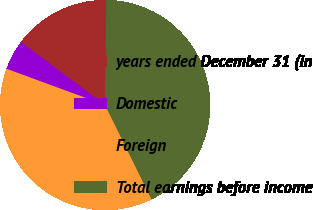Convert chart. <chart><loc_0><loc_0><loc_500><loc_500><pie_chart><fcel>years ended December 31 (in<fcel>Domestic<fcel>Foreign<fcel>Total earnings before income<nl><fcel>14.95%<fcel>4.64%<fcel>37.88%<fcel>42.53%<nl></chart> 